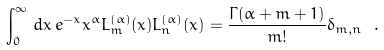<formula> <loc_0><loc_0><loc_500><loc_500>\int _ { 0 } ^ { \infty } \, d x \, e ^ { - x } x ^ { \alpha } L _ { m } ^ { ( \alpha ) } ( x ) L _ { n } ^ { ( \alpha ) } ( x ) = \frac { \Gamma ( \alpha + m + 1 ) } { m ! } \delta _ { m , n } \ .</formula> 